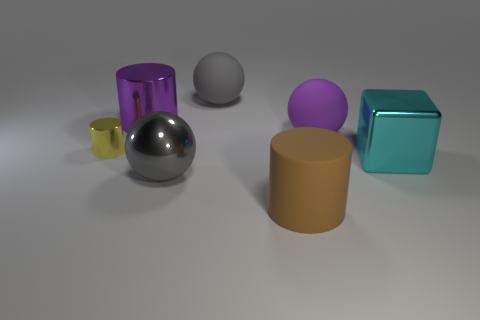If these objects are symbolic, what might they represent? If we were to interpret the objects symbolically, the variety in shapes and colors could represent diversity and uniqueness. The shiny cylinders might symbolize innovation and technology due to their industrial look, while the cube could represent stability and order. The matte objects, by contrast, could suggest nature and the organic, due to their earthy tones and less reflective surfaces. 